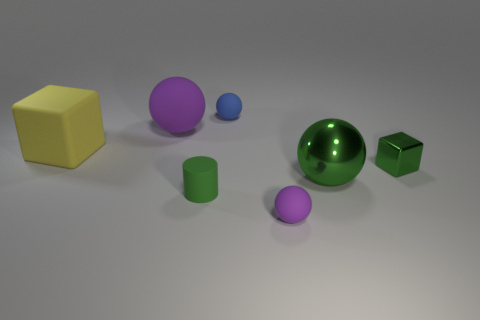Are there any small matte things of the same color as the big metal ball?
Your answer should be compact. Yes. What is the size of the green thing on the left side of the purple ball in front of the big sphere that is in front of the big block?
Your answer should be compact. Small. The yellow thing has what shape?
Offer a very short reply. Cube. There is a thing that is the same color as the large rubber ball; what is its size?
Provide a succinct answer. Small. There is a purple ball in front of the large yellow block; how many tiny purple rubber spheres are to the right of it?
Offer a very short reply. 0. What number of other things are there of the same material as the green ball
Ensure brevity in your answer.  1. Is the ball that is on the left side of the blue ball made of the same material as the cube that is behind the tiny green cube?
Offer a terse response. Yes. Is there anything else that has the same shape as the large shiny thing?
Provide a short and direct response. Yes. Do the blue object and the tiny object that is right of the shiny sphere have the same material?
Offer a very short reply. No. There is a large rubber thing that is left of the purple matte sphere that is on the left side of the purple matte thing that is in front of the green ball; what color is it?
Your response must be concise. Yellow. 